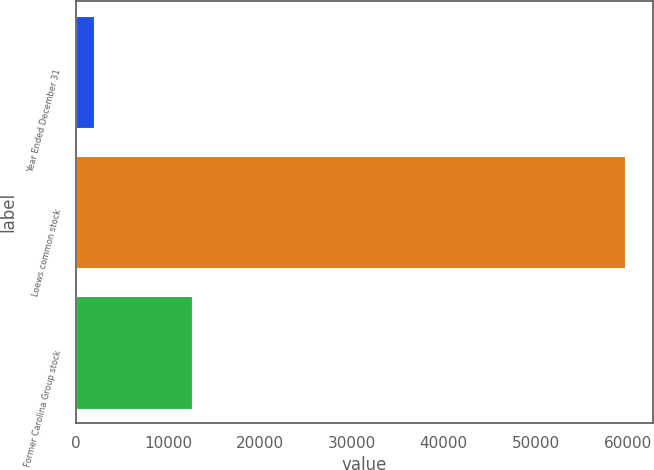Convert chart. <chart><loc_0><loc_0><loc_500><loc_500><bar_chart><fcel>Year Ended December 31<fcel>Loews common stock<fcel>Former Carolina Group stock<nl><fcel>2006<fcel>59744<fcel>12650<nl></chart> 